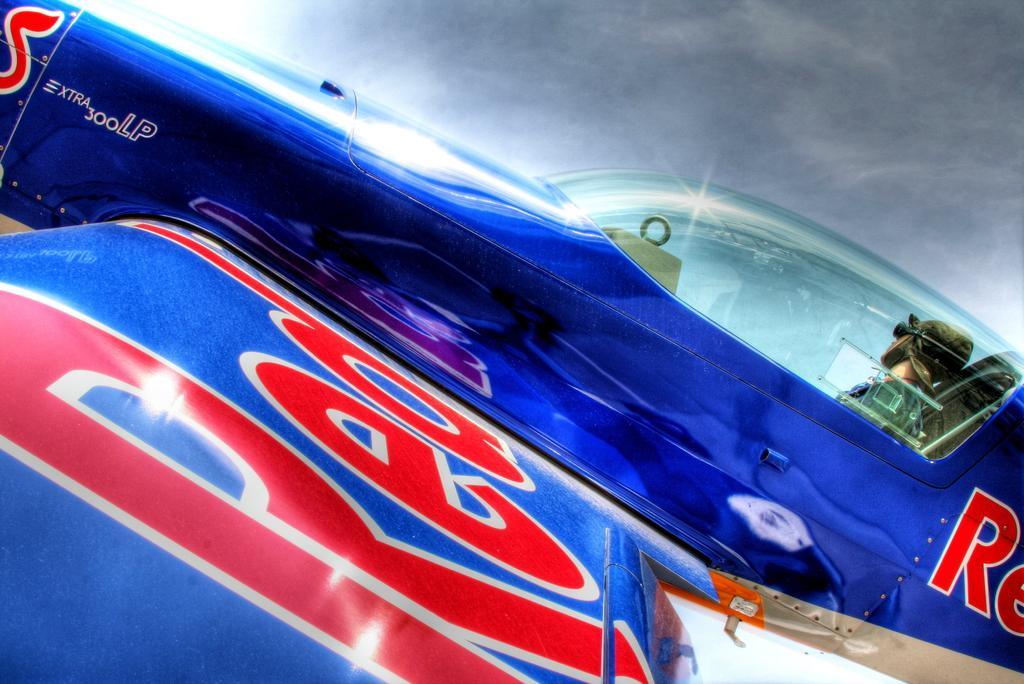<image>
Relay a brief, clear account of the picture shown. Red and blue plane that has the word "Red" on the wing. 